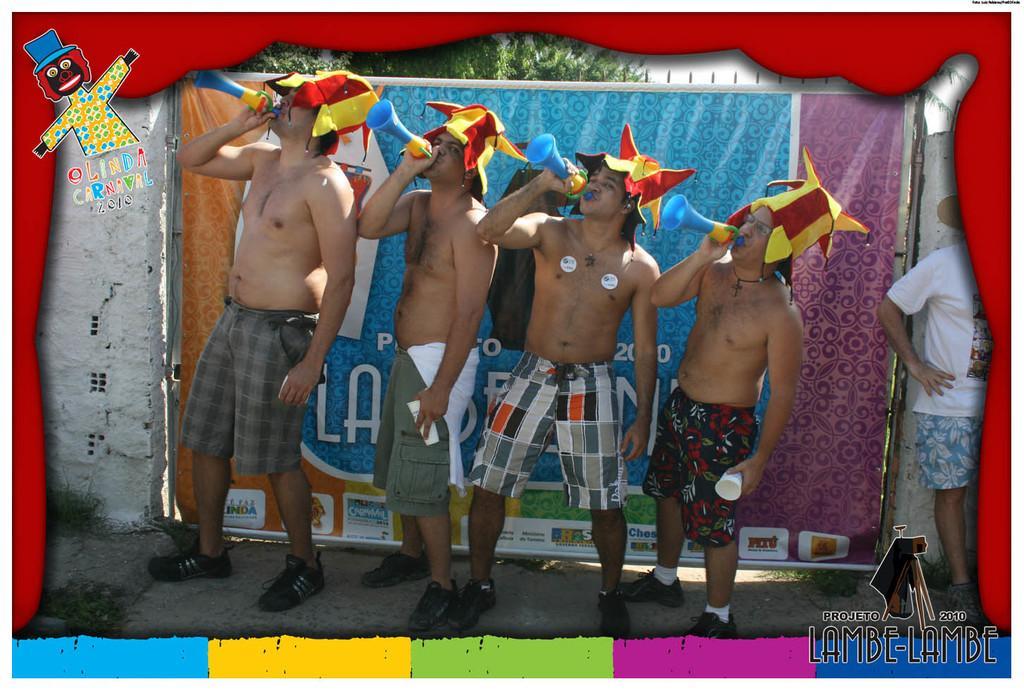Could you give a brief overview of what you see in this image? In the image we can see five men standing, wearing clothes and shoes and four of them are wearing joker cap and holding object in hands. Here we can see banner, wall, trees and footpath. Here we can see watermark. 